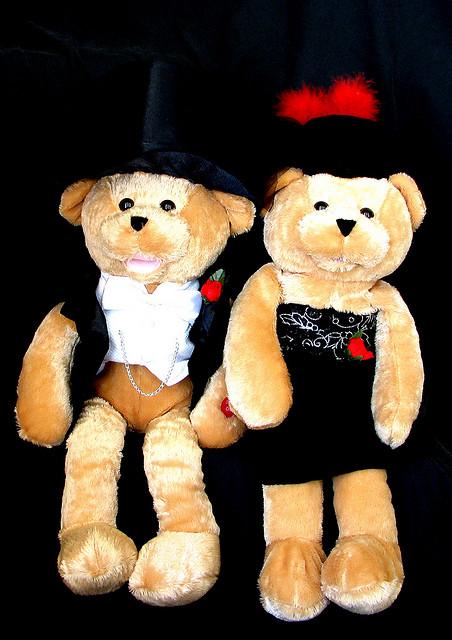Is there a different teddy bear?
Write a very short answer. Yes. Which bear is wearing a hat?
Keep it brief. Both. How many of the teddy bears have pants?
Quick response, please. 0. Are the teddie dressed?
Answer briefly. Yes. 